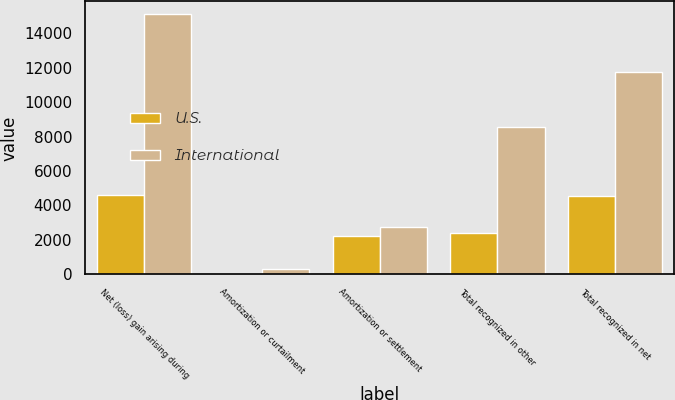Convert chart. <chart><loc_0><loc_0><loc_500><loc_500><stacked_bar_chart><ecel><fcel>Net (loss) gain arising during<fcel>Amortization or curtailment<fcel>Amortization or settlement<fcel>Total recognized in other<fcel>Total recognized in net<nl><fcel>U.S.<fcel>4613<fcel>23<fcel>2197<fcel>2393<fcel>4541<nl><fcel>International<fcel>15098<fcel>313<fcel>2768<fcel>8557<fcel>11777<nl></chart> 